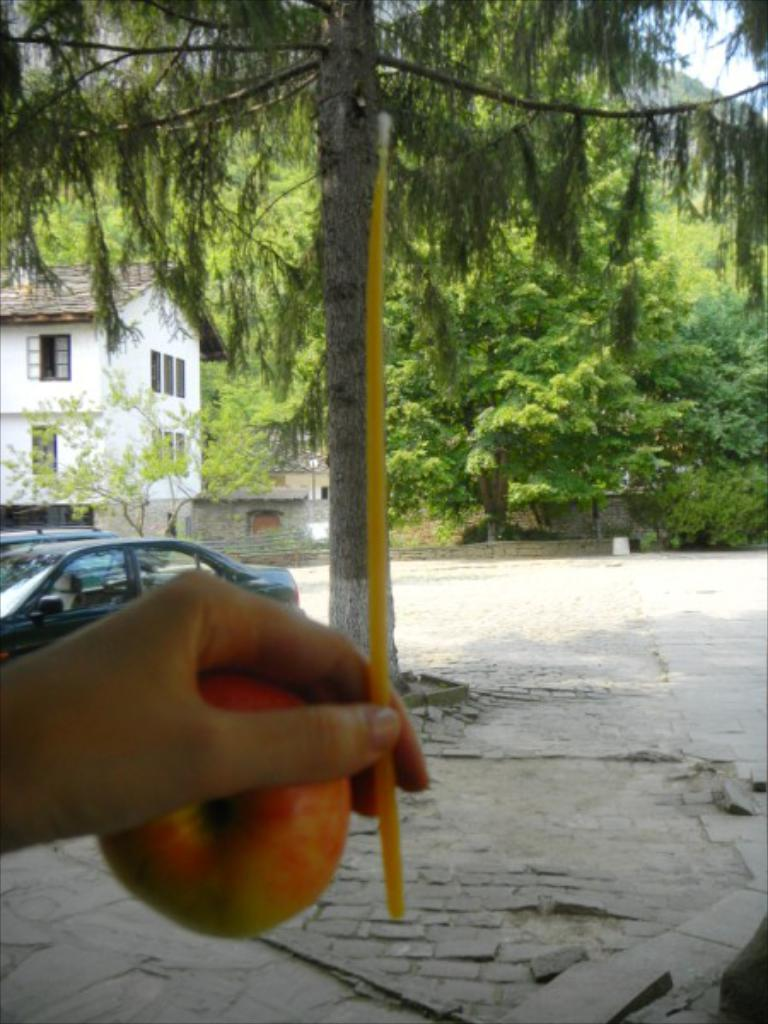What type of structure is visible in the image? There is a building in the image. What natural elements can be seen in the image? There are trees in the image. What man-made objects are present in the image? There are cars in the image. What is being held by a human hand in the image? A human hand is holding an apple in the image. What type of wax is being used to cover the building in the image? There is no wax or covering process mentioned in the image; it simply shows a building, trees, cars, and a hand holding an apple. 